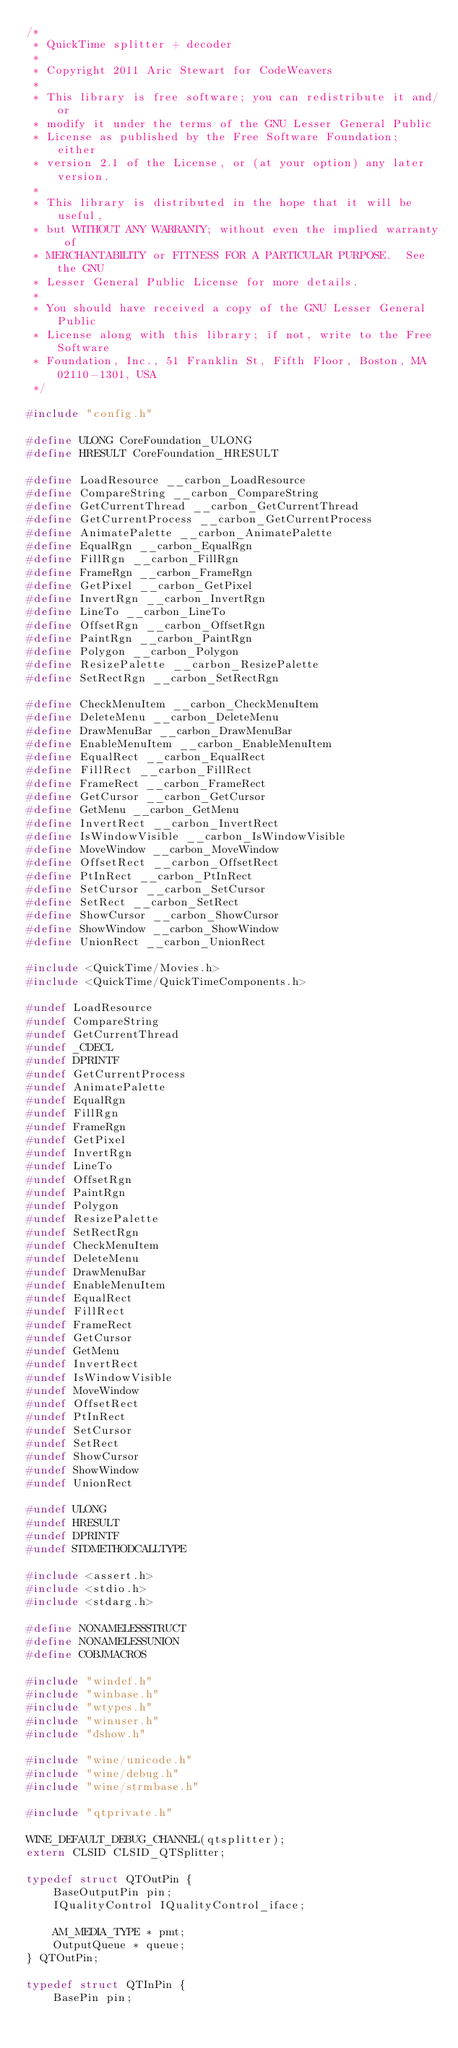<code> <loc_0><loc_0><loc_500><loc_500><_C_>/*
 * QuickTime splitter + decoder
 *
 * Copyright 2011 Aric Stewart for CodeWeavers
 *
 * This library is free software; you can redistribute it and/or
 * modify it under the terms of the GNU Lesser General Public
 * License as published by the Free Software Foundation; either
 * version 2.1 of the License, or (at your option) any later version.
 *
 * This library is distributed in the hope that it will be useful,
 * but WITHOUT ANY WARRANTY; without even the implied warranty of
 * MERCHANTABILITY or FITNESS FOR A PARTICULAR PURPOSE.  See the GNU
 * Lesser General Public License for more details.
 *
 * You should have received a copy of the GNU Lesser General Public
 * License along with this library; if not, write to the Free Software
 * Foundation, Inc., 51 Franklin St, Fifth Floor, Boston, MA 02110-1301, USA
 */

#include "config.h"

#define ULONG CoreFoundation_ULONG
#define HRESULT CoreFoundation_HRESULT

#define LoadResource __carbon_LoadResource
#define CompareString __carbon_CompareString
#define GetCurrentThread __carbon_GetCurrentThread
#define GetCurrentProcess __carbon_GetCurrentProcess
#define AnimatePalette __carbon_AnimatePalette
#define EqualRgn __carbon_EqualRgn
#define FillRgn __carbon_FillRgn
#define FrameRgn __carbon_FrameRgn
#define GetPixel __carbon_GetPixel
#define InvertRgn __carbon_InvertRgn
#define LineTo __carbon_LineTo
#define OffsetRgn __carbon_OffsetRgn
#define PaintRgn __carbon_PaintRgn
#define Polygon __carbon_Polygon
#define ResizePalette __carbon_ResizePalette
#define SetRectRgn __carbon_SetRectRgn

#define CheckMenuItem __carbon_CheckMenuItem
#define DeleteMenu __carbon_DeleteMenu
#define DrawMenuBar __carbon_DrawMenuBar
#define EnableMenuItem __carbon_EnableMenuItem
#define EqualRect __carbon_EqualRect
#define FillRect __carbon_FillRect
#define FrameRect __carbon_FrameRect
#define GetCursor __carbon_GetCursor
#define GetMenu __carbon_GetMenu
#define InvertRect __carbon_InvertRect
#define IsWindowVisible __carbon_IsWindowVisible
#define MoveWindow __carbon_MoveWindow
#define OffsetRect __carbon_OffsetRect
#define PtInRect __carbon_PtInRect
#define SetCursor __carbon_SetCursor
#define SetRect __carbon_SetRect
#define ShowCursor __carbon_ShowCursor
#define ShowWindow __carbon_ShowWindow
#define UnionRect __carbon_UnionRect

#include <QuickTime/Movies.h>
#include <QuickTime/QuickTimeComponents.h>

#undef LoadResource
#undef CompareString
#undef GetCurrentThread
#undef _CDECL
#undef DPRINTF
#undef GetCurrentProcess
#undef AnimatePalette
#undef EqualRgn
#undef FillRgn
#undef FrameRgn
#undef GetPixel
#undef InvertRgn
#undef LineTo
#undef OffsetRgn
#undef PaintRgn
#undef Polygon
#undef ResizePalette
#undef SetRectRgn
#undef CheckMenuItem
#undef DeleteMenu
#undef DrawMenuBar
#undef EnableMenuItem
#undef EqualRect
#undef FillRect
#undef FrameRect
#undef GetCursor
#undef GetMenu
#undef InvertRect
#undef IsWindowVisible
#undef MoveWindow
#undef OffsetRect
#undef PtInRect
#undef SetCursor
#undef SetRect
#undef ShowCursor
#undef ShowWindow
#undef UnionRect

#undef ULONG
#undef HRESULT
#undef DPRINTF
#undef STDMETHODCALLTYPE

#include <assert.h>
#include <stdio.h>
#include <stdarg.h>

#define NONAMELESSSTRUCT
#define NONAMELESSUNION
#define COBJMACROS

#include "windef.h"
#include "winbase.h"
#include "wtypes.h"
#include "winuser.h"
#include "dshow.h"

#include "wine/unicode.h"
#include "wine/debug.h"
#include "wine/strmbase.h"

#include "qtprivate.h"

WINE_DEFAULT_DEBUG_CHANNEL(qtsplitter);
extern CLSID CLSID_QTSplitter;

typedef struct QTOutPin {
    BaseOutputPin pin;
    IQualityControl IQualityControl_iface;

    AM_MEDIA_TYPE * pmt;
    OutputQueue * queue;
} QTOutPin;

typedef struct QTInPin {
    BasePin pin;</code> 